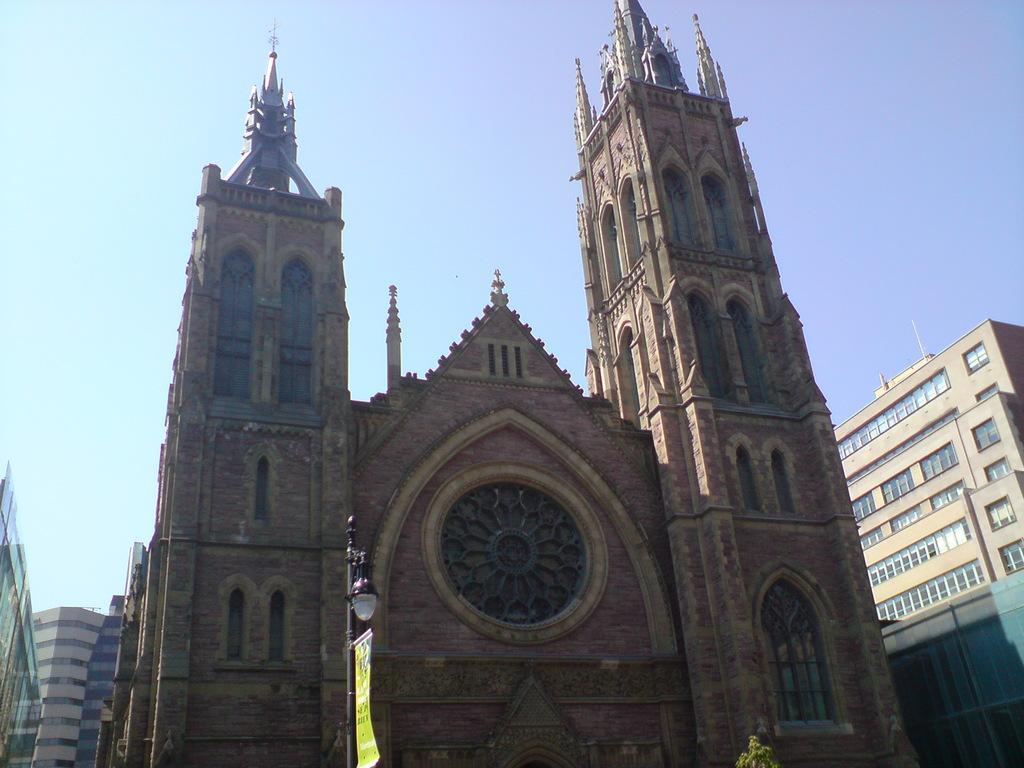Could you give a brief overview of what you see in this image? In this image we can see one big church in the middle of the image, some buildings, one tree, one light with pole in front of the church and at the top there is the sky. 